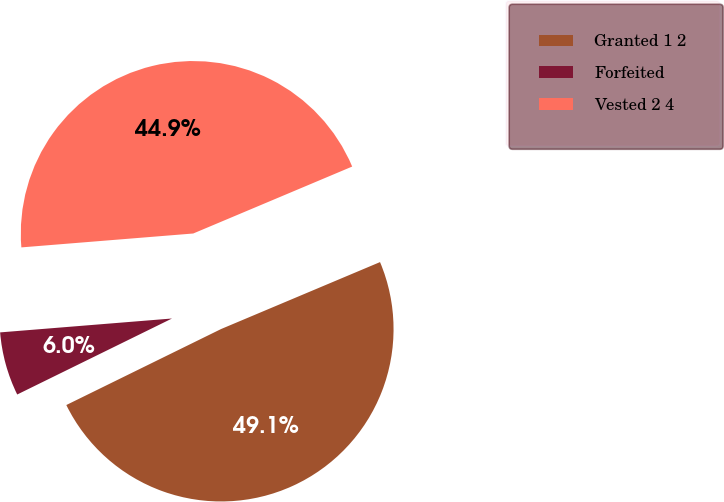<chart> <loc_0><loc_0><loc_500><loc_500><pie_chart><fcel>Granted 1 2<fcel>Forfeited<fcel>Vested 2 4<nl><fcel>49.08%<fcel>5.98%<fcel>44.94%<nl></chart> 